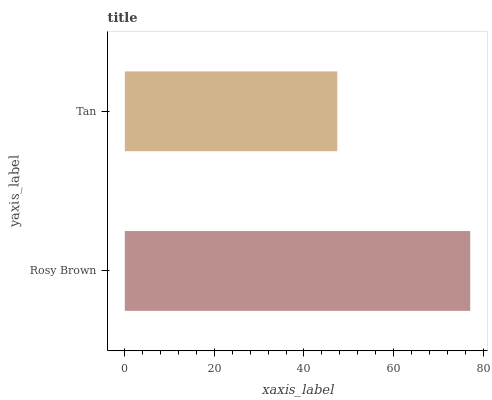Is Tan the minimum?
Answer yes or no. Yes. Is Rosy Brown the maximum?
Answer yes or no. Yes. Is Tan the maximum?
Answer yes or no. No. Is Rosy Brown greater than Tan?
Answer yes or no. Yes. Is Tan less than Rosy Brown?
Answer yes or no. Yes. Is Tan greater than Rosy Brown?
Answer yes or no. No. Is Rosy Brown less than Tan?
Answer yes or no. No. Is Rosy Brown the high median?
Answer yes or no. Yes. Is Tan the low median?
Answer yes or no. Yes. Is Tan the high median?
Answer yes or no. No. Is Rosy Brown the low median?
Answer yes or no. No. 